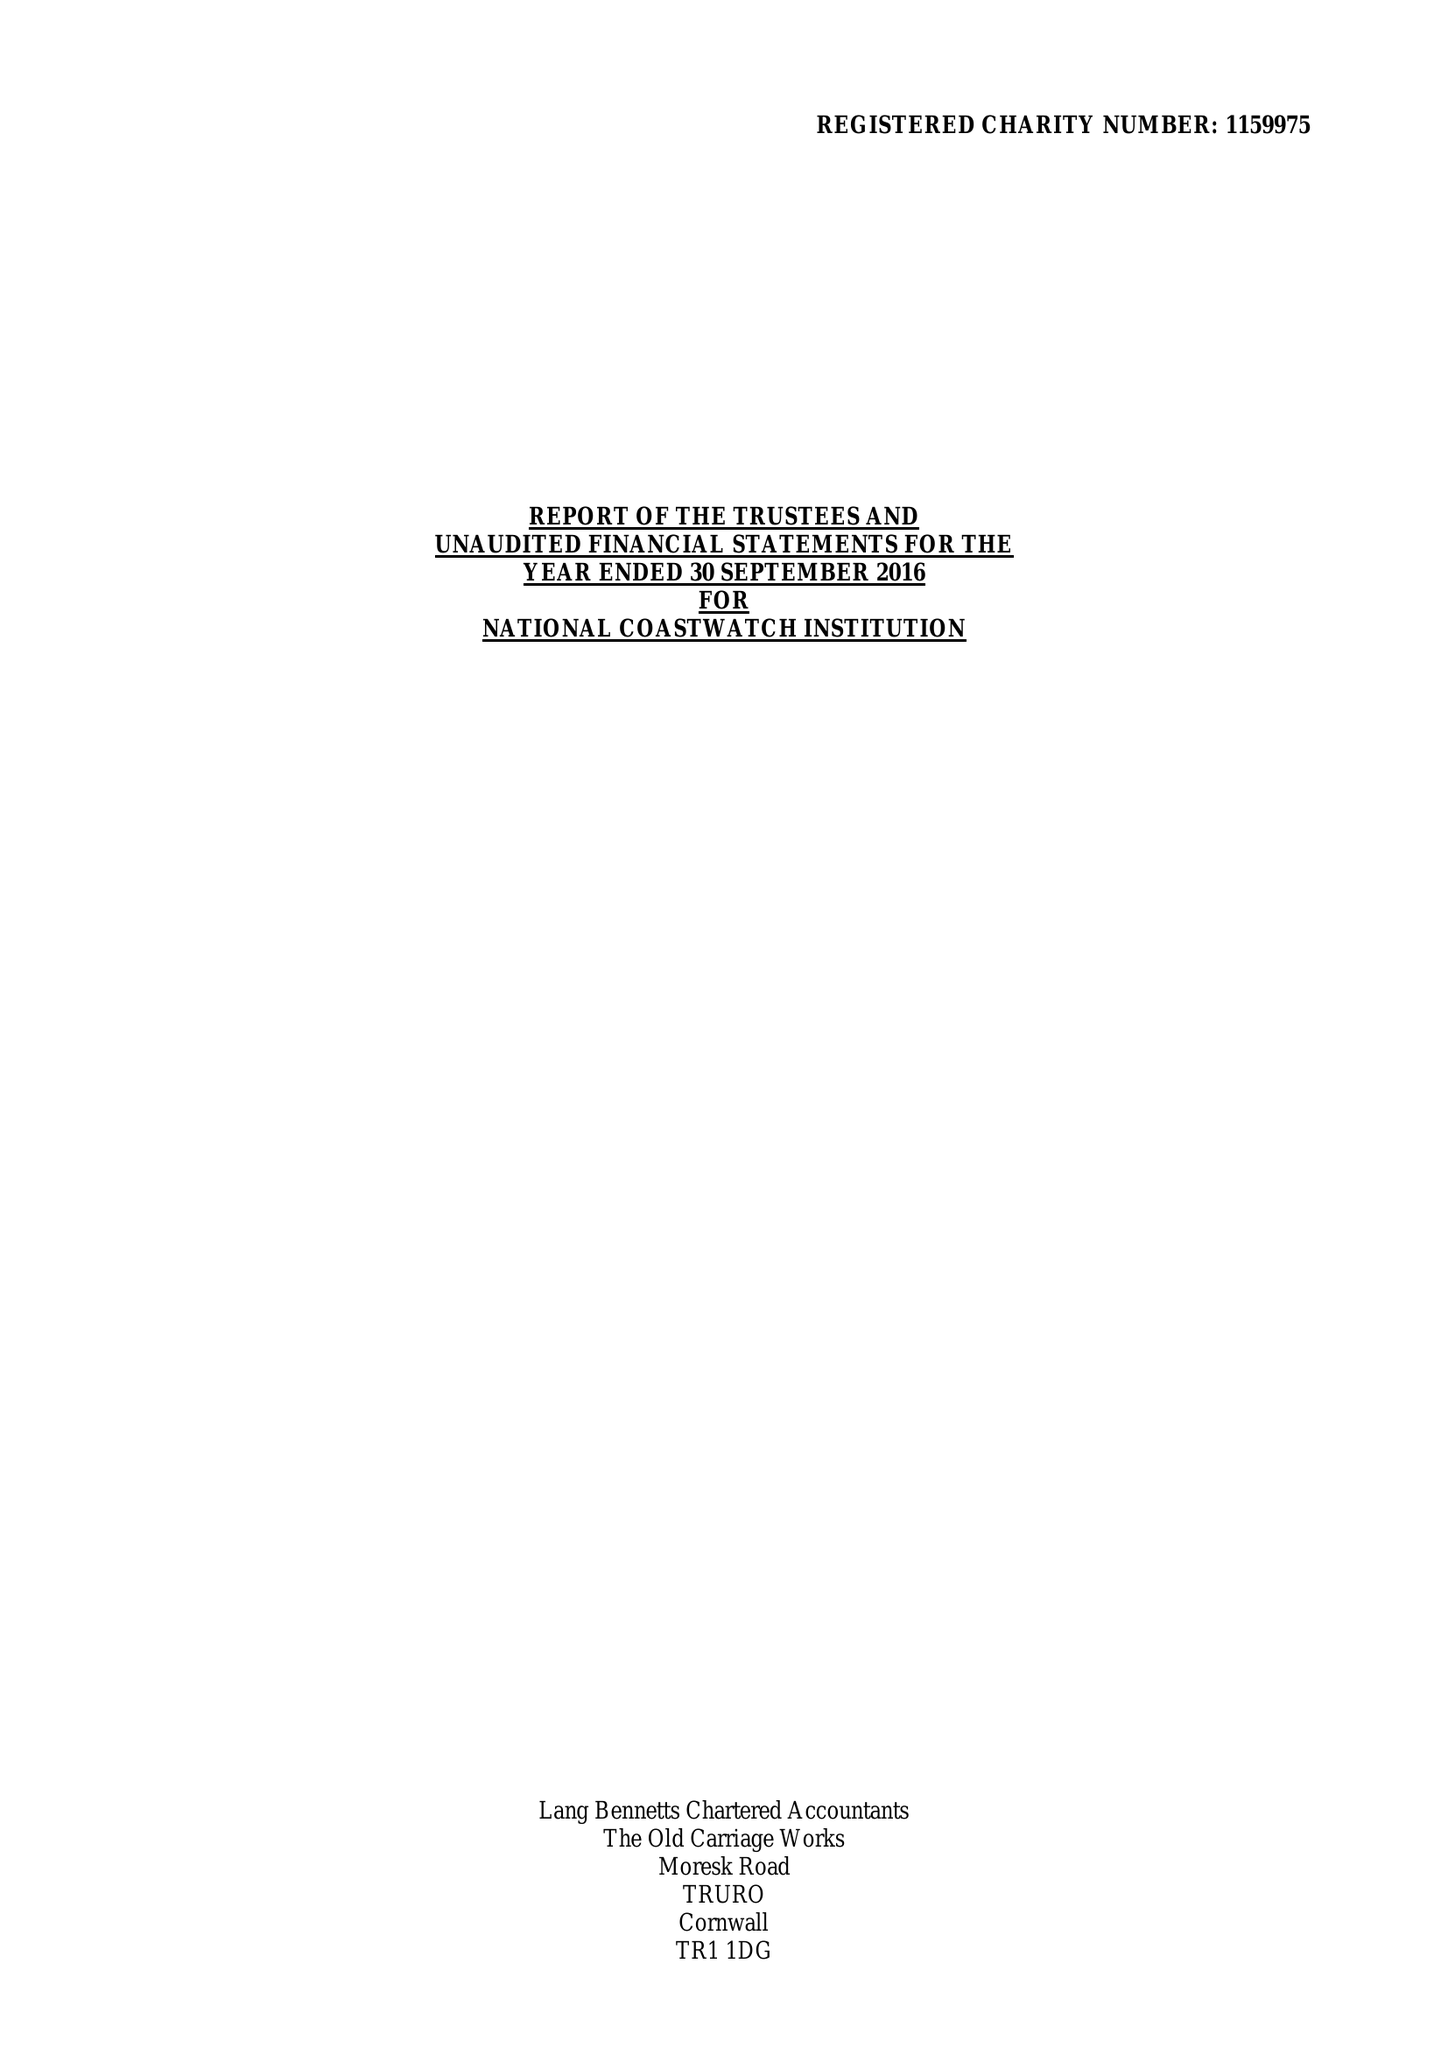What is the value for the address__postcode?
Answer the question using a single word or phrase. PL14 4AB 